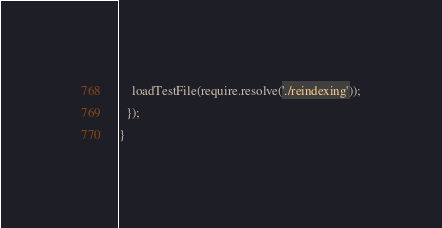<code> <loc_0><loc_0><loc_500><loc_500><_JavaScript_>    loadTestFile(require.resolve('./reindexing'));
  });
}
</code> 